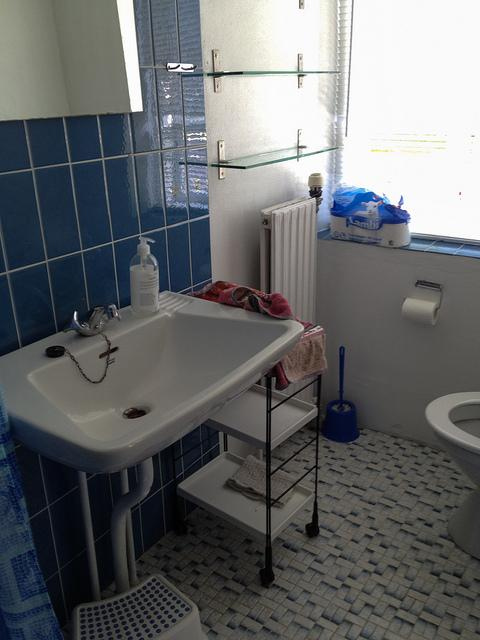What is usually done here?

Choices:
A) sleeping
B) teeth brushing
C) watching tv
D) cooking eggs teeth brushing 